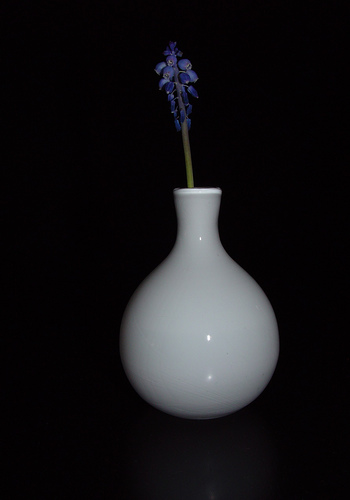What can you tell me about the lighting and background? The image is characterized by a predominately dark background that enhances the visibility and luminescence of the white vase and the blue flower. The lighting appears to be focused on the foreground, subtly highlighting the contours of the vase and the delicate structure of the flower, creating a soft shadow beneath the vase. 